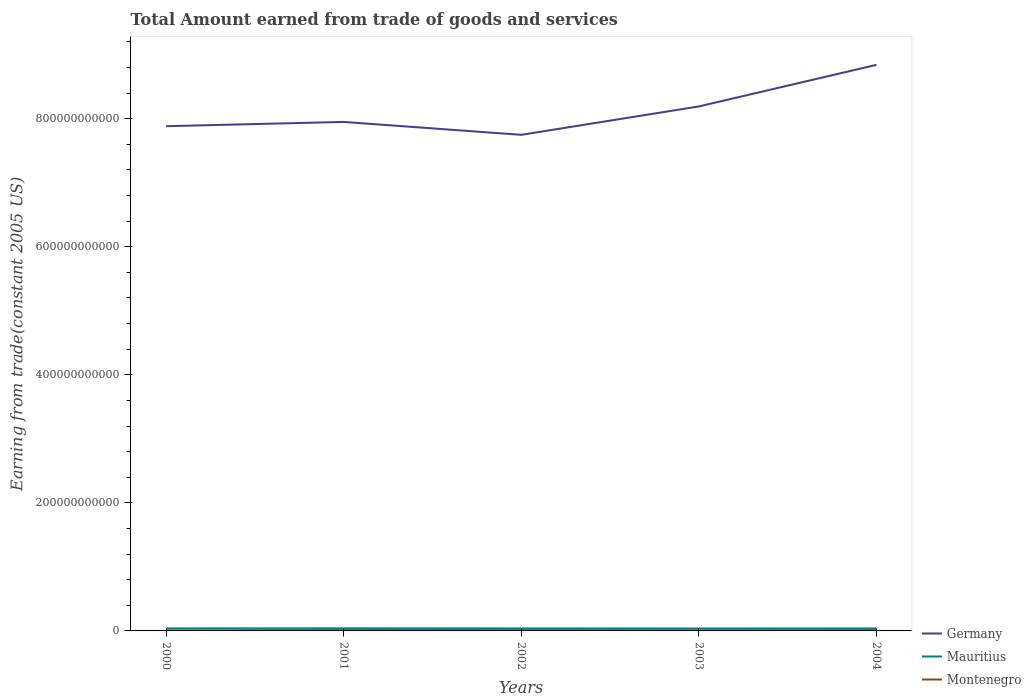Does the line corresponding to Montenegro intersect with the line corresponding to Mauritius?
Keep it short and to the point. No. Across all years, what is the maximum total amount earned by trading goods and services in Germany?
Keep it short and to the point. 7.75e+11. What is the total total amount earned by trading goods and services in Germany in the graph?
Offer a terse response. -8.91e+1. What is the difference between the highest and the second highest total amount earned by trading goods and services in Germany?
Provide a short and direct response. 1.09e+11. How many lines are there?
Keep it short and to the point. 3. What is the difference between two consecutive major ticks on the Y-axis?
Make the answer very short. 2.00e+11. Are the values on the major ticks of Y-axis written in scientific E-notation?
Your answer should be compact. No. Does the graph contain any zero values?
Your response must be concise. No. Does the graph contain grids?
Give a very brief answer. No. How many legend labels are there?
Your answer should be compact. 3. What is the title of the graph?
Offer a very short reply. Total Amount earned from trade of goods and services. What is the label or title of the X-axis?
Offer a terse response. Years. What is the label or title of the Y-axis?
Make the answer very short. Earning from trade(constant 2005 US). What is the Earning from trade(constant 2005 US) of Germany in 2000?
Keep it short and to the point. 7.88e+11. What is the Earning from trade(constant 2005 US) of Mauritius in 2000?
Offer a terse response. 3.92e+09. What is the Earning from trade(constant 2005 US) in Montenegro in 2000?
Give a very brief answer. 7.19e+08. What is the Earning from trade(constant 2005 US) of Germany in 2001?
Provide a short and direct response. 7.95e+11. What is the Earning from trade(constant 2005 US) in Mauritius in 2001?
Your answer should be compact. 4.04e+09. What is the Earning from trade(constant 2005 US) in Montenegro in 2001?
Offer a terse response. 1.18e+09. What is the Earning from trade(constant 2005 US) in Germany in 2002?
Offer a very short reply. 7.75e+11. What is the Earning from trade(constant 2005 US) of Mauritius in 2002?
Offer a very short reply. 3.91e+09. What is the Earning from trade(constant 2005 US) of Montenegro in 2002?
Offer a terse response. 1.22e+09. What is the Earning from trade(constant 2005 US) in Germany in 2003?
Provide a succinct answer. 8.19e+11. What is the Earning from trade(constant 2005 US) in Mauritius in 2003?
Your answer should be very brief. 3.78e+09. What is the Earning from trade(constant 2005 US) of Montenegro in 2003?
Keep it short and to the point. 9.18e+08. What is the Earning from trade(constant 2005 US) of Germany in 2004?
Offer a terse response. 8.84e+11. What is the Earning from trade(constant 2005 US) in Mauritius in 2004?
Offer a very short reply. 3.89e+09. What is the Earning from trade(constant 2005 US) of Montenegro in 2004?
Your answer should be very brief. 1.21e+09. Across all years, what is the maximum Earning from trade(constant 2005 US) in Germany?
Keep it short and to the point. 8.84e+11. Across all years, what is the maximum Earning from trade(constant 2005 US) of Mauritius?
Ensure brevity in your answer.  4.04e+09. Across all years, what is the maximum Earning from trade(constant 2005 US) in Montenegro?
Your response must be concise. 1.22e+09. Across all years, what is the minimum Earning from trade(constant 2005 US) in Germany?
Your answer should be compact. 7.75e+11. Across all years, what is the minimum Earning from trade(constant 2005 US) of Mauritius?
Your answer should be compact. 3.78e+09. Across all years, what is the minimum Earning from trade(constant 2005 US) in Montenegro?
Provide a short and direct response. 7.19e+08. What is the total Earning from trade(constant 2005 US) of Germany in the graph?
Provide a short and direct response. 4.06e+12. What is the total Earning from trade(constant 2005 US) in Mauritius in the graph?
Keep it short and to the point. 1.95e+1. What is the total Earning from trade(constant 2005 US) of Montenegro in the graph?
Your answer should be very brief. 5.25e+09. What is the difference between the Earning from trade(constant 2005 US) of Germany in 2000 and that in 2001?
Ensure brevity in your answer.  -6.68e+09. What is the difference between the Earning from trade(constant 2005 US) in Mauritius in 2000 and that in 2001?
Keep it short and to the point. -1.17e+08. What is the difference between the Earning from trade(constant 2005 US) of Montenegro in 2000 and that in 2001?
Offer a terse response. -4.62e+08. What is the difference between the Earning from trade(constant 2005 US) in Germany in 2000 and that in 2002?
Ensure brevity in your answer.  1.35e+1. What is the difference between the Earning from trade(constant 2005 US) in Mauritius in 2000 and that in 2002?
Ensure brevity in your answer.  1.39e+07. What is the difference between the Earning from trade(constant 2005 US) in Montenegro in 2000 and that in 2002?
Keep it short and to the point. -4.99e+08. What is the difference between the Earning from trade(constant 2005 US) in Germany in 2000 and that in 2003?
Your response must be concise. -3.09e+1. What is the difference between the Earning from trade(constant 2005 US) in Mauritius in 2000 and that in 2003?
Ensure brevity in your answer.  1.37e+08. What is the difference between the Earning from trade(constant 2005 US) in Montenegro in 2000 and that in 2003?
Your answer should be compact. -1.99e+08. What is the difference between the Earning from trade(constant 2005 US) of Germany in 2000 and that in 2004?
Make the answer very short. -9.58e+1. What is the difference between the Earning from trade(constant 2005 US) of Mauritius in 2000 and that in 2004?
Your answer should be compact. 3.03e+07. What is the difference between the Earning from trade(constant 2005 US) in Montenegro in 2000 and that in 2004?
Offer a very short reply. -4.94e+08. What is the difference between the Earning from trade(constant 2005 US) in Germany in 2001 and that in 2002?
Offer a very short reply. 2.02e+1. What is the difference between the Earning from trade(constant 2005 US) of Mauritius in 2001 and that in 2002?
Your response must be concise. 1.30e+08. What is the difference between the Earning from trade(constant 2005 US) of Montenegro in 2001 and that in 2002?
Your answer should be compact. -3.63e+07. What is the difference between the Earning from trade(constant 2005 US) of Germany in 2001 and that in 2003?
Provide a short and direct response. -2.42e+1. What is the difference between the Earning from trade(constant 2005 US) of Mauritius in 2001 and that in 2003?
Make the answer very short. 2.53e+08. What is the difference between the Earning from trade(constant 2005 US) of Montenegro in 2001 and that in 2003?
Your response must be concise. 2.63e+08. What is the difference between the Earning from trade(constant 2005 US) of Germany in 2001 and that in 2004?
Provide a succinct answer. -8.91e+1. What is the difference between the Earning from trade(constant 2005 US) of Mauritius in 2001 and that in 2004?
Make the answer very short. 1.47e+08. What is the difference between the Earning from trade(constant 2005 US) of Montenegro in 2001 and that in 2004?
Offer a very short reply. -3.18e+07. What is the difference between the Earning from trade(constant 2005 US) of Germany in 2002 and that in 2003?
Ensure brevity in your answer.  -4.43e+1. What is the difference between the Earning from trade(constant 2005 US) in Mauritius in 2002 and that in 2003?
Provide a short and direct response. 1.23e+08. What is the difference between the Earning from trade(constant 2005 US) of Montenegro in 2002 and that in 2003?
Offer a terse response. 3.00e+08. What is the difference between the Earning from trade(constant 2005 US) of Germany in 2002 and that in 2004?
Make the answer very short. -1.09e+11. What is the difference between the Earning from trade(constant 2005 US) of Mauritius in 2002 and that in 2004?
Your response must be concise. 1.64e+07. What is the difference between the Earning from trade(constant 2005 US) of Montenegro in 2002 and that in 2004?
Offer a very short reply. 4.53e+06. What is the difference between the Earning from trade(constant 2005 US) of Germany in 2003 and that in 2004?
Offer a terse response. -6.50e+1. What is the difference between the Earning from trade(constant 2005 US) of Mauritius in 2003 and that in 2004?
Offer a very short reply. -1.06e+08. What is the difference between the Earning from trade(constant 2005 US) in Montenegro in 2003 and that in 2004?
Ensure brevity in your answer.  -2.95e+08. What is the difference between the Earning from trade(constant 2005 US) in Germany in 2000 and the Earning from trade(constant 2005 US) in Mauritius in 2001?
Keep it short and to the point. 7.84e+11. What is the difference between the Earning from trade(constant 2005 US) in Germany in 2000 and the Earning from trade(constant 2005 US) in Montenegro in 2001?
Keep it short and to the point. 7.87e+11. What is the difference between the Earning from trade(constant 2005 US) in Mauritius in 2000 and the Earning from trade(constant 2005 US) in Montenegro in 2001?
Make the answer very short. 2.74e+09. What is the difference between the Earning from trade(constant 2005 US) of Germany in 2000 and the Earning from trade(constant 2005 US) of Mauritius in 2002?
Offer a terse response. 7.84e+11. What is the difference between the Earning from trade(constant 2005 US) in Germany in 2000 and the Earning from trade(constant 2005 US) in Montenegro in 2002?
Offer a terse response. 7.87e+11. What is the difference between the Earning from trade(constant 2005 US) of Mauritius in 2000 and the Earning from trade(constant 2005 US) of Montenegro in 2002?
Ensure brevity in your answer.  2.70e+09. What is the difference between the Earning from trade(constant 2005 US) of Germany in 2000 and the Earning from trade(constant 2005 US) of Mauritius in 2003?
Keep it short and to the point. 7.85e+11. What is the difference between the Earning from trade(constant 2005 US) of Germany in 2000 and the Earning from trade(constant 2005 US) of Montenegro in 2003?
Your response must be concise. 7.87e+11. What is the difference between the Earning from trade(constant 2005 US) in Mauritius in 2000 and the Earning from trade(constant 2005 US) in Montenegro in 2003?
Provide a short and direct response. 3.00e+09. What is the difference between the Earning from trade(constant 2005 US) in Germany in 2000 and the Earning from trade(constant 2005 US) in Mauritius in 2004?
Give a very brief answer. 7.84e+11. What is the difference between the Earning from trade(constant 2005 US) in Germany in 2000 and the Earning from trade(constant 2005 US) in Montenegro in 2004?
Offer a very short reply. 7.87e+11. What is the difference between the Earning from trade(constant 2005 US) of Mauritius in 2000 and the Earning from trade(constant 2005 US) of Montenegro in 2004?
Your answer should be compact. 2.71e+09. What is the difference between the Earning from trade(constant 2005 US) of Germany in 2001 and the Earning from trade(constant 2005 US) of Mauritius in 2002?
Your answer should be very brief. 7.91e+11. What is the difference between the Earning from trade(constant 2005 US) in Germany in 2001 and the Earning from trade(constant 2005 US) in Montenegro in 2002?
Your answer should be compact. 7.94e+11. What is the difference between the Earning from trade(constant 2005 US) in Mauritius in 2001 and the Earning from trade(constant 2005 US) in Montenegro in 2002?
Provide a short and direct response. 2.82e+09. What is the difference between the Earning from trade(constant 2005 US) of Germany in 2001 and the Earning from trade(constant 2005 US) of Mauritius in 2003?
Provide a short and direct response. 7.91e+11. What is the difference between the Earning from trade(constant 2005 US) of Germany in 2001 and the Earning from trade(constant 2005 US) of Montenegro in 2003?
Your answer should be very brief. 7.94e+11. What is the difference between the Earning from trade(constant 2005 US) of Mauritius in 2001 and the Earning from trade(constant 2005 US) of Montenegro in 2003?
Your response must be concise. 3.12e+09. What is the difference between the Earning from trade(constant 2005 US) of Germany in 2001 and the Earning from trade(constant 2005 US) of Mauritius in 2004?
Ensure brevity in your answer.  7.91e+11. What is the difference between the Earning from trade(constant 2005 US) in Germany in 2001 and the Earning from trade(constant 2005 US) in Montenegro in 2004?
Provide a short and direct response. 7.94e+11. What is the difference between the Earning from trade(constant 2005 US) in Mauritius in 2001 and the Earning from trade(constant 2005 US) in Montenegro in 2004?
Give a very brief answer. 2.82e+09. What is the difference between the Earning from trade(constant 2005 US) of Germany in 2002 and the Earning from trade(constant 2005 US) of Mauritius in 2003?
Your answer should be very brief. 7.71e+11. What is the difference between the Earning from trade(constant 2005 US) of Germany in 2002 and the Earning from trade(constant 2005 US) of Montenegro in 2003?
Your answer should be compact. 7.74e+11. What is the difference between the Earning from trade(constant 2005 US) in Mauritius in 2002 and the Earning from trade(constant 2005 US) in Montenegro in 2003?
Give a very brief answer. 2.99e+09. What is the difference between the Earning from trade(constant 2005 US) of Germany in 2002 and the Earning from trade(constant 2005 US) of Mauritius in 2004?
Provide a succinct answer. 7.71e+11. What is the difference between the Earning from trade(constant 2005 US) of Germany in 2002 and the Earning from trade(constant 2005 US) of Montenegro in 2004?
Offer a terse response. 7.74e+11. What is the difference between the Earning from trade(constant 2005 US) of Mauritius in 2002 and the Earning from trade(constant 2005 US) of Montenegro in 2004?
Offer a terse response. 2.69e+09. What is the difference between the Earning from trade(constant 2005 US) of Germany in 2003 and the Earning from trade(constant 2005 US) of Mauritius in 2004?
Your answer should be very brief. 8.15e+11. What is the difference between the Earning from trade(constant 2005 US) of Germany in 2003 and the Earning from trade(constant 2005 US) of Montenegro in 2004?
Your answer should be compact. 8.18e+11. What is the difference between the Earning from trade(constant 2005 US) in Mauritius in 2003 and the Earning from trade(constant 2005 US) in Montenegro in 2004?
Your answer should be compact. 2.57e+09. What is the average Earning from trade(constant 2005 US) in Germany per year?
Keep it short and to the point. 8.12e+11. What is the average Earning from trade(constant 2005 US) of Mauritius per year?
Give a very brief answer. 3.91e+09. What is the average Earning from trade(constant 2005 US) in Montenegro per year?
Offer a terse response. 1.05e+09. In the year 2000, what is the difference between the Earning from trade(constant 2005 US) of Germany and Earning from trade(constant 2005 US) of Mauritius?
Give a very brief answer. 7.84e+11. In the year 2000, what is the difference between the Earning from trade(constant 2005 US) of Germany and Earning from trade(constant 2005 US) of Montenegro?
Your response must be concise. 7.88e+11. In the year 2000, what is the difference between the Earning from trade(constant 2005 US) in Mauritius and Earning from trade(constant 2005 US) in Montenegro?
Offer a very short reply. 3.20e+09. In the year 2001, what is the difference between the Earning from trade(constant 2005 US) of Germany and Earning from trade(constant 2005 US) of Mauritius?
Offer a very short reply. 7.91e+11. In the year 2001, what is the difference between the Earning from trade(constant 2005 US) in Germany and Earning from trade(constant 2005 US) in Montenegro?
Your answer should be very brief. 7.94e+11. In the year 2001, what is the difference between the Earning from trade(constant 2005 US) of Mauritius and Earning from trade(constant 2005 US) of Montenegro?
Keep it short and to the point. 2.86e+09. In the year 2002, what is the difference between the Earning from trade(constant 2005 US) of Germany and Earning from trade(constant 2005 US) of Mauritius?
Offer a terse response. 7.71e+11. In the year 2002, what is the difference between the Earning from trade(constant 2005 US) of Germany and Earning from trade(constant 2005 US) of Montenegro?
Make the answer very short. 7.74e+11. In the year 2002, what is the difference between the Earning from trade(constant 2005 US) in Mauritius and Earning from trade(constant 2005 US) in Montenegro?
Your answer should be compact. 2.69e+09. In the year 2003, what is the difference between the Earning from trade(constant 2005 US) in Germany and Earning from trade(constant 2005 US) in Mauritius?
Ensure brevity in your answer.  8.15e+11. In the year 2003, what is the difference between the Earning from trade(constant 2005 US) in Germany and Earning from trade(constant 2005 US) in Montenegro?
Ensure brevity in your answer.  8.18e+11. In the year 2003, what is the difference between the Earning from trade(constant 2005 US) of Mauritius and Earning from trade(constant 2005 US) of Montenegro?
Ensure brevity in your answer.  2.87e+09. In the year 2004, what is the difference between the Earning from trade(constant 2005 US) of Germany and Earning from trade(constant 2005 US) of Mauritius?
Provide a short and direct response. 8.80e+11. In the year 2004, what is the difference between the Earning from trade(constant 2005 US) in Germany and Earning from trade(constant 2005 US) in Montenegro?
Offer a terse response. 8.83e+11. In the year 2004, what is the difference between the Earning from trade(constant 2005 US) of Mauritius and Earning from trade(constant 2005 US) of Montenegro?
Your answer should be compact. 2.68e+09. What is the ratio of the Earning from trade(constant 2005 US) in Germany in 2000 to that in 2001?
Ensure brevity in your answer.  0.99. What is the ratio of the Earning from trade(constant 2005 US) in Mauritius in 2000 to that in 2001?
Give a very brief answer. 0.97. What is the ratio of the Earning from trade(constant 2005 US) in Montenegro in 2000 to that in 2001?
Keep it short and to the point. 0.61. What is the ratio of the Earning from trade(constant 2005 US) of Germany in 2000 to that in 2002?
Provide a short and direct response. 1.02. What is the ratio of the Earning from trade(constant 2005 US) of Montenegro in 2000 to that in 2002?
Offer a terse response. 0.59. What is the ratio of the Earning from trade(constant 2005 US) of Germany in 2000 to that in 2003?
Ensure brevity in your answer.  0.96. What is the ratio of the Earning from trade(constant 2005 US) in Mauritius in 2000 to that in 2003?
Keep it short and to the point. 1.04. What is the ratio of the Earning from trade(constant 2005 US) in Montenegro in 2000 to that in 2003?
Your answer should be very brief. 0.78. What is the ratio of the Earning from trade(constant 2005 US) of Germany in 2000 to that in 2004?
Provide a short and direct response. 0.89. What is the ratio of the Earning from trade(constant 2005 US) of Mauritius in 2000 to that in 2004?
Provide a succinct answer. 1.01. What is the ratio of the Earning from trade(constant 2005 US) in Montenegro in 2000 to that in 2004?
Offer a terse response. 0.59. What is the ratio of the Earning from trade(constant 2005 US) of Germany in 2001 to that in 2002?
Provide a short and direct response. 1.03. What is the ratio of the Earning from trade(constant 2005 US) in Mauritius in 2001 to that in 2002?
Ensure brevity in your answer.  1.03. What is the ratio of the Earning from trade(constant 2005 US) of Montenegro in 2001 to that in 2002?
Provide a succinct answer. 0.97. What is the ratio of the Earning from trade(constant 2005 US) of Germany in 2001 to that in 2003?
Offer a very short reply. 0.97. What is the ratio of the Earning from trade(constant 2005 US) of Mauritius in 2001 to that in 2003?
Your answer should be compact. 1.07. What is the ratio of the Earning from trade(constant 2005 US) of Montenegro in 2001 to that in 2003?
Give a very brief answer. 1.29. What is the ratio of the Earning from trade(constant 2005 US) of Germany in 2001 to that in 2004?
Keep it short and to the point. 0.9. What is the ratio of the Earning from trade(constant 2005 US) in Mauritius in 2001 to that in 2004?
Provide a succinct answer. 1.04. What is the ratio of the Earning from trade(constant 2005 US) of Montenegro in 2001 to that in 2004?
Provide a succinct answer. 0.97. What is the ratio of the Earning from trade(constant 2005 US) in Germany in 2002 to that in 2003?
Offer a very short reply. 0.95. What is the ratio of the Earning from trade(constant 2005 US) in Mauritius in 2002 to that in 2003?
Provide a succinct answer. 1.03. What is the ratio of the Earning from trade(constant 2005 US) in Montenegro in 2002 to that in 2003?
Offer a very short reply. 1.33. What is the ratio of the Earning from trade(constant 2005 US) of Germany in 2002 to that in 2004?
Give a very brief answer. 0.88. What is the ratio of the Earning from trade(constant 2005 US) of Montenegro in 2002 to that in 2004?
Offer a terse response. 1. What is the ratio of the Earning from trade(constant 2005 US) of Germany in 2003 to that in 2004?
Provide a succinct answer. 0.93. What is the ratio of the Earning from trade(constant 2005 US) of Mauritius in 2003 to that in 2004?
Give a very brief answer. 0.97. What is the ratio of the Earning from trade(constant 2005 US) in Montenegro in 2003 to that in 2004?
Ensure brevity in your answer.  0.76. What is the difference between the highest and the second highest Earning from trade(constant 2005 US) in Germany?
Your response must be concise. 6.50e+1. What is the difference between the highest and the second highest Earning from trade(constant 2005 US) of Mauritius?
Provide a short and direct response. 1.17e+08. What is the difference between the highest and the second highest Earning from trade(constant 2005 US) in Montenegro?
Ensure brevity in your answer.  4.53e+06. What is the difference between the highest and the lowest Earning from trade(constant 2005 US) of Germany?
Offer a terse response. 1.09e+11. What is the difference between the highest and the lowest Earning from trade(constant 2005 US) in Mauritius?
Provide a succinct answer. 2.53e+08. What is the difference between the highest and the lowest Earning from trade(constant 2005 US) of Montenegro?
Your answer should be very brief. 4.99e+08. 